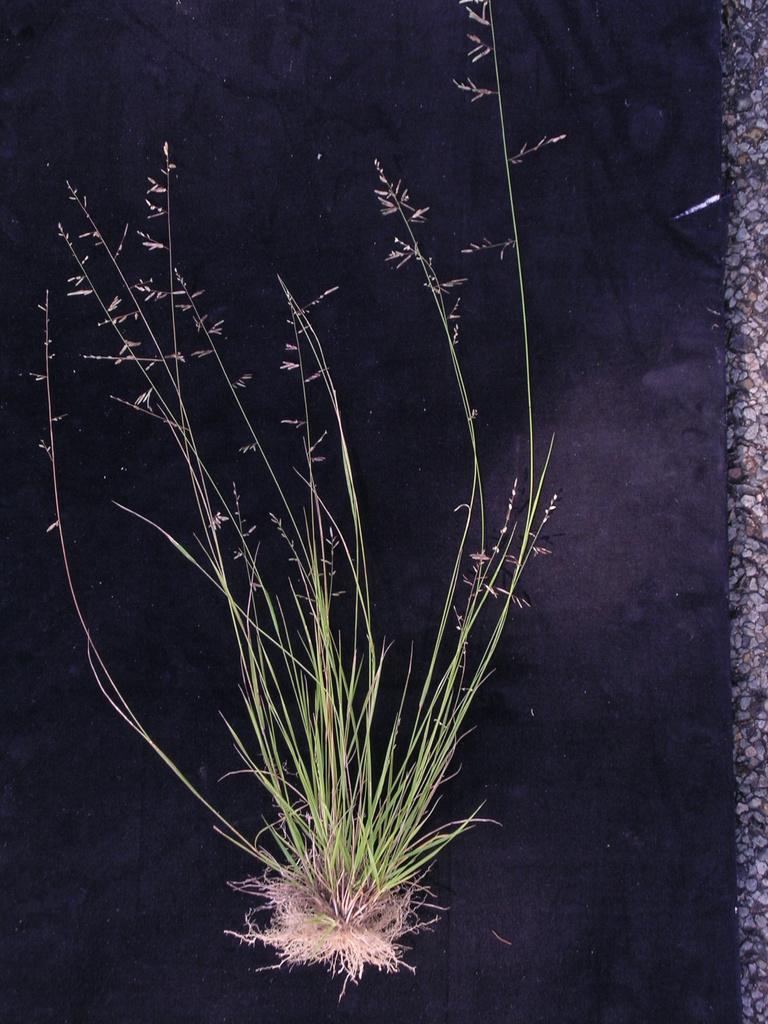Describe this image in one or two sentences. There is a plant, it has roots. There is a black background. 